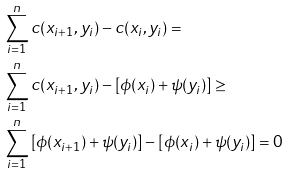Convert formula to latex. <formula><loc_0><loc_0><loc_500><loc_500>& \sum _ { i = 1 } ^ { n } c ( x _ { i + 1 } , y _ { i } ) - c ( x _ { i } , y _ { i } ) = \\ & \sum _ { i = 1 } ^ { n } c ( x _ { i + 1 } , y _ { i } ) - \left [ \phi ( x _ { i } ) + \psi ( y _ { i } ) \right ] \geq \\ & \sum _ { i = 1 } ^ { n } \left [ \phi ( x _ { i + 1 } ) + \psi ( y _ { i } ) \right ] - \left [ \phi ( x _ { i } ) + \psi ( y _ { i } ) \right ] = 0</formula> 